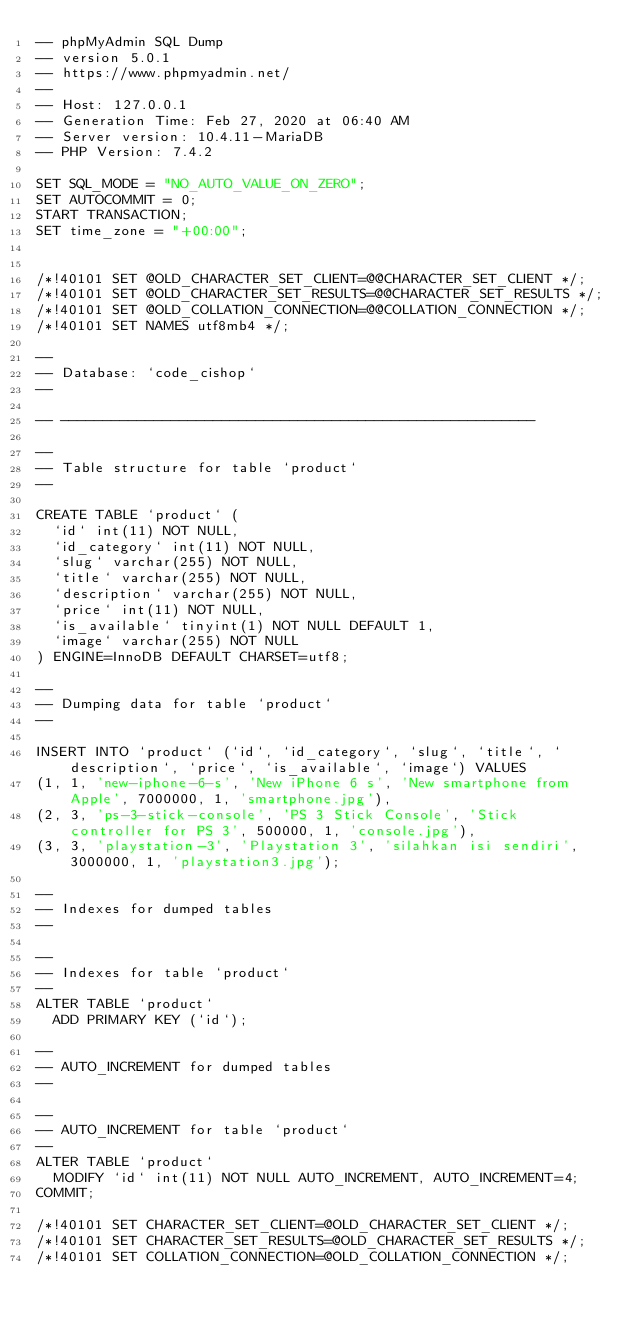Convert code to text. <code><loc_0><loc_0><loc_500><loc_500><_SQL_>-- phpMyAdmin SQL Dump
-- version 5.0.1
-- https://www.phpmyadmin.net/
--
-- Host: 127.0.0.1
-- Generation Time: Feb 27, 2020 at 06:40 AM
-- Server version: 10.4.11-MariaDB
-- PHP Version: 7.4.2

SET SQL_MODE = "NO_AUTO_VALUE_ON_ZERO";
SET AUTOCOMMIT = 0;
START TRANSACTION;
SET time_zone = "+00:00";


/*!40101 SET @OLD_CHARACTER_SET_CLIENT=@@CHARACTER_SET_CLIENT */;
/*!40101 SET @OLD_CHARACTER_SET_RESULTS=@@CHARACTER_SET_RESULTS */;
/*!40101 SET @OLD_COLLATION_CONNECTION=@@COLLATION_CONNECTION */;
/*!40101 SET NAMES utf8mb4 */;

--
-- Database: `code_cishop`
--

-- --------------------------------------------------------

--
-- Table structure for table `product`
--

CREATE TABLE `product` (
  `id` int(11) NOT NULL,
  `id_category` int(11) NOT NULL,
  `slug` varchar(255) NOT NULL,
  `title` varchar(255) NOT NULL,
  `description` varchar(255) NOT NULL,
  `price` int(11) NOT NULL,
  `is_available` tinyint(1) NOT NULL DEFAULT 1,
  `image` varchar(255) NOT NULL
) ENGINE=InnoDB DEFAULT CHARSET=utf8;

--
-- Dumping data for table `product`
--

INSERT INTO `product` (`id`, `id_category`, `slug`, `title`, `description`, `price`, `is_available`, `image`) VALUES
(1, 1, 'new-iphone-6-s', 'New iPhone 6 s', 'New smartphone from Apple', 7000000, 1, 'smartphone.jpg'),
(2, 3, 'ps-3-stick-console', 'PS 3 Stick Console', 'Stick controller for PS 3', 500000, 1, 'console.jpg'),
(3, 3, 'playstation-3', 'Playstation 3', 'silahkan isi sendiri', 3000000, 1, 'playstation3.jpg');

--
-- Indexes for dumped tables
--

--
-- Indexes for table `product`
--
ALTER TABLE `product`
  ADD PRIMARY KEY (`id`);

--
-- AUTO_INCREMENT for dumped tables
--

--
-- AUTO_INCREMENT for table `product`
--
ALTER TABLE `product`
  MODIFY `id` int(11) NOT NULL AUTO_INCREMENT, AUTO_INCREMENT=4;
COMMIT;

/*!40101 SET CHARACTER_SET_CLIENT=@OLD_CHARACTER_SET_CLIENT */;
/*!40101 SET CHARACTER_SET_RESULTS=@OLD_CHARACTER_SET_RESULTS */;
/*!40101 SET COLLATION_CONNECTION=@OLD_COLLATION_CONNECTION */;
</code> 